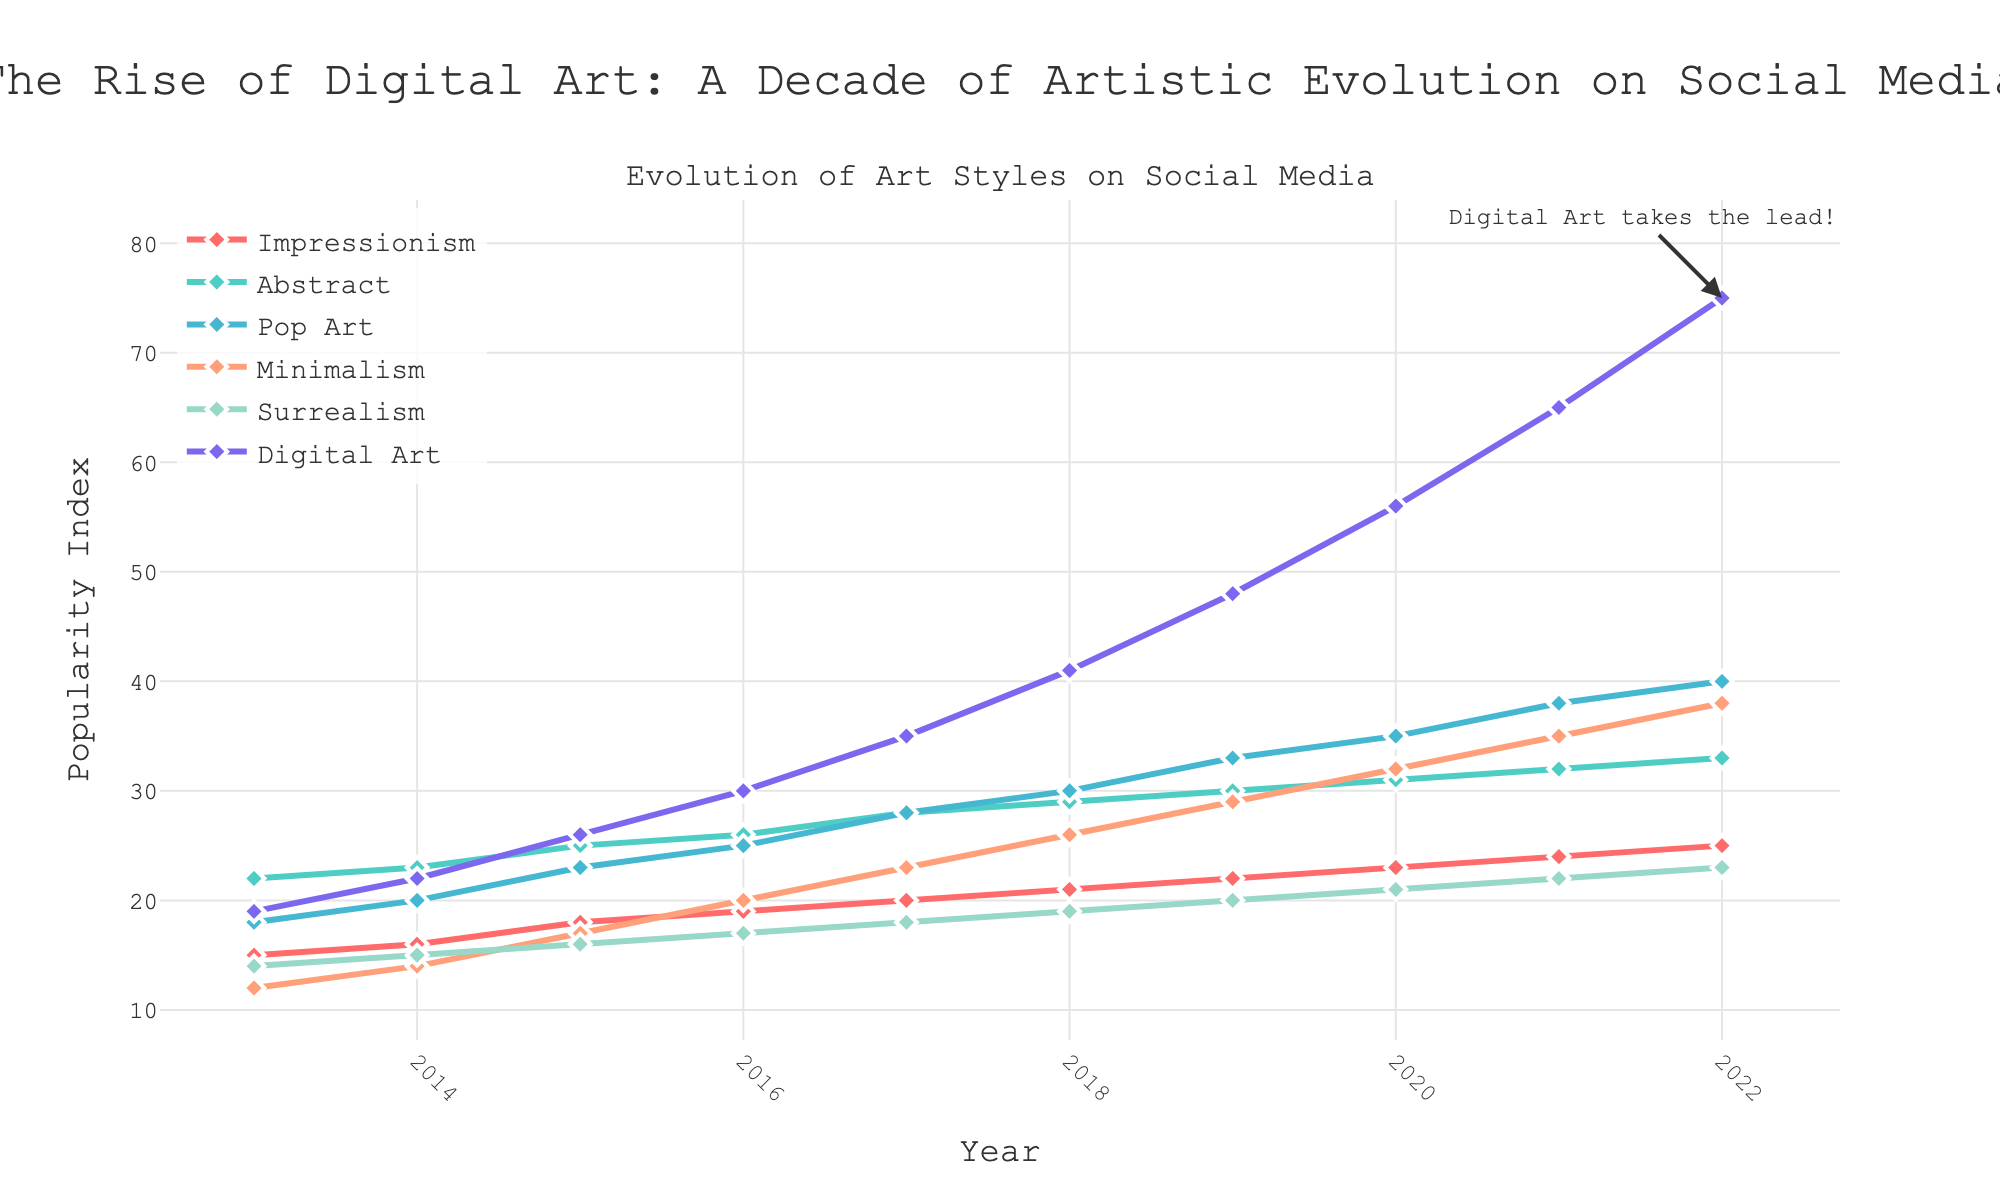Which art style showed the highest increase in popularity from 2013 to 2022? To determine the highest increase, we need to subtract the popularity values of 2013 from those of 2022 for each art style and compare the differences. Digital Art increased from 19 to 75, giving an increase of 75 - 19 = 56. This is the highest among all styles.
Answer: Digital Art Which art style had the most stable popularity trend over the decade? To determine the most stable trend, we look for the art style with the smallest changes (least variation) in popularity values over the years. Minimalism increased from 12 to 38, showing a relatively less steep incline compared to others. Thus, it exhibited a more stable trend.
Answer: Minimalism In what year did Pop Art surpass Minimalism in popularity? We examine the lines for Pop Art and Minimalism. The intersection occurs between 2015 and 2016. Therefore, the first full year where Pop Art surpassed Minimalism was 2016.
Answer: 2016 What was the popularity index for Abstract art in 2020? By locating the year 2020 on the x-axis and then finding the corresponding y-value for Abstract art, we find the popularity index for Abstract art in 2020 was 31.
Answer: 31 By how much did Surrealism increase from 2013 to 2019? Subtract the popularity index of Surrealism in 2013 from its index in 2019. The values are 20 in 2019 and 14 in 2013, so the increase is 20 - 14 = 6.
Answer: 6 Which year witnessed the largest increase in Digital Art popularity? Observing the steepness of the curve for Digital Art, the largest single year increase appears between 2021 and 2022. The increase is from 65 to 75, a change of 75 - 65 = 10.
Answer: 2021 to 2022 How does the popularity of Impressionism in 2022 compare to its popularity in 2016? The values for Impressionism are 25 in 2022 and 19 in 2016. By comparing them, we see that it increased by 25 - 19 = 6.
Answer: It increased by 6 What is the total popularity increase for Minimalism from 2013 to 2022? Subtract the 2013 popularity value (12) from the 2022 value (38) for Minimalism, which results in a total increase of 38 - 12 = 26.
Answer: 26 Which art style was the least popular in 2013, and what was its popularity index? From the 2013 values, Minimalism has the lowest index at 12.
Answer: Minimalism, 12 Between which consecutive years did Impressionism see the smallest increase in popularity? By calculating the year-over-year increases, we find the smallest increase between 2018 and 2019 (21 to 22), an increase of just 1.
Answer: 2018 to 2019 